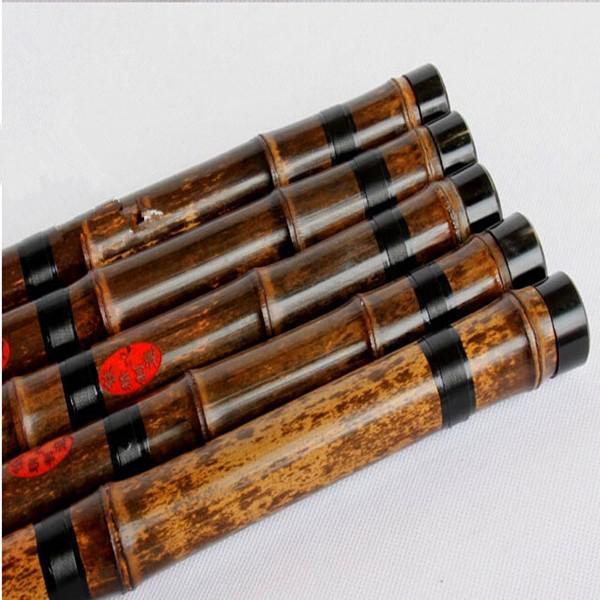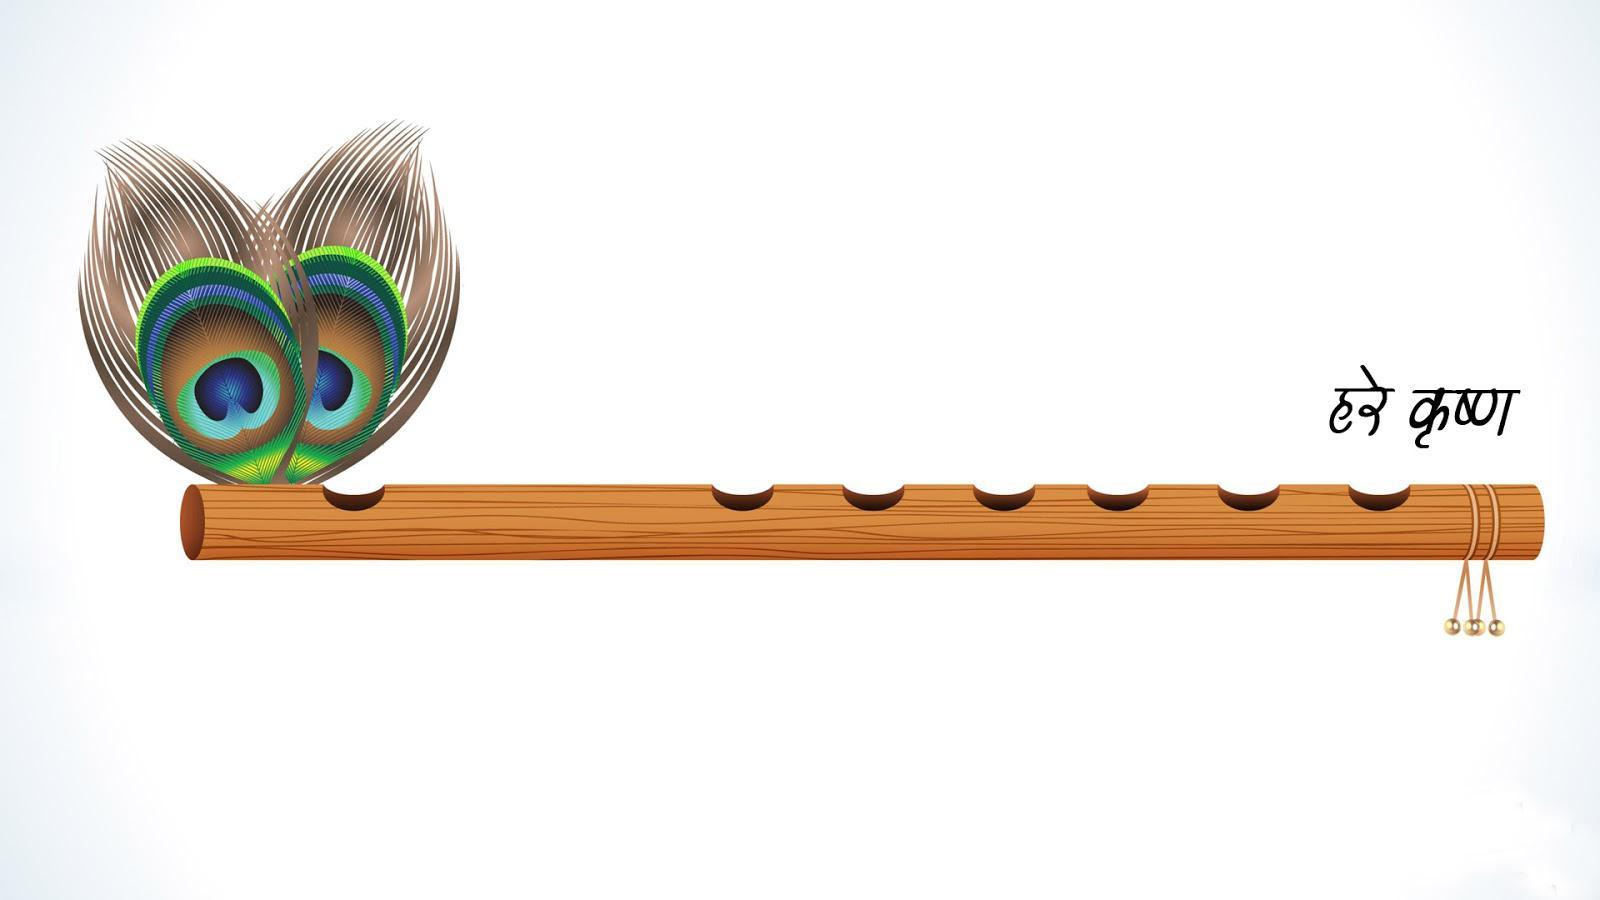The first image is the image on the left, the second image is the image on the right. Evaluate the accuracy of this statement regarding the images: "There is a single instrument in each of the images, one of which is a flute.". Is it true? Answer yes or no. No. The first image is the image on the left, the second image is the image on the right. For the images displayed, is the sentence "One image shows a horizontal row of round metal keys with open centers on a tube-shaped metal instrument, and the other image shows one wooden flute with holes but no keys and several stripes around it." factually correct? Answer yes or no. No. 